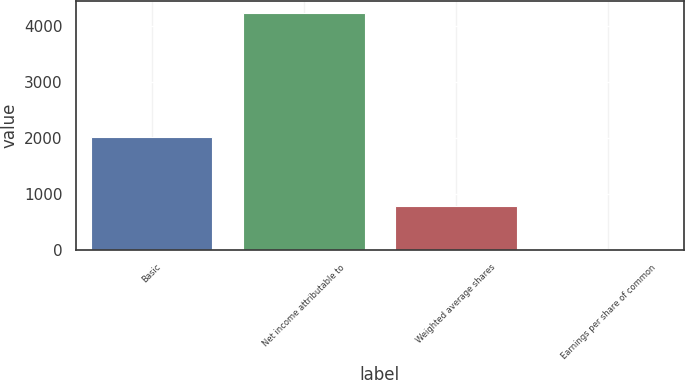Convert chart to OTSL. <chart><loc_0><loc_0><loc_500><loc_500><bar_chart><fcel>Basic<fcel>Net income attributable to<fcel>Weighted average shares<fcel>Earnings per share of common<nl><fcel>2014<fcel>4239<fcel>784.4<fcel>5.4<nl></chart> 